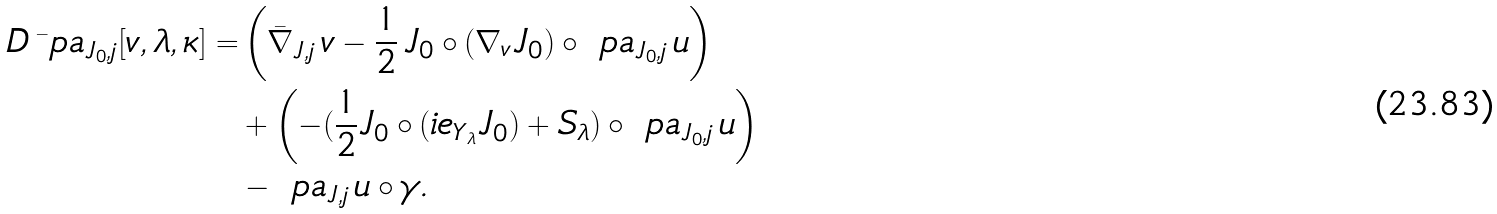Convert formula to latex. <formula><loc_0><loc_0><loc_500><loc_500>D \, \bar { \ } p a _ { J _ { 0 } , j } [ v , \lambda , \kappa ] = & \left ( \bar { \nabla } _ { J , j } \, v - \frac { 1 } { 2 } \, J _ { 0 } \circ ( \nabla _ { v } J _ { 0 } ) \circ \ p a _ { J _ { 0 } , j } \, u \right ) \\ & + \left ( - ( \frac { 1 } { 2 } J _ { 0 } \circ ( \L i e _ { Y _ { \lambda } } J _ { 0 } ) + S _ { \lambda } ) \circ \ p a _ { J _ { 0 } , j } \, u \right ) \\ & - \ p a _ { J , j } \, u \circ \gamma .</formula> 